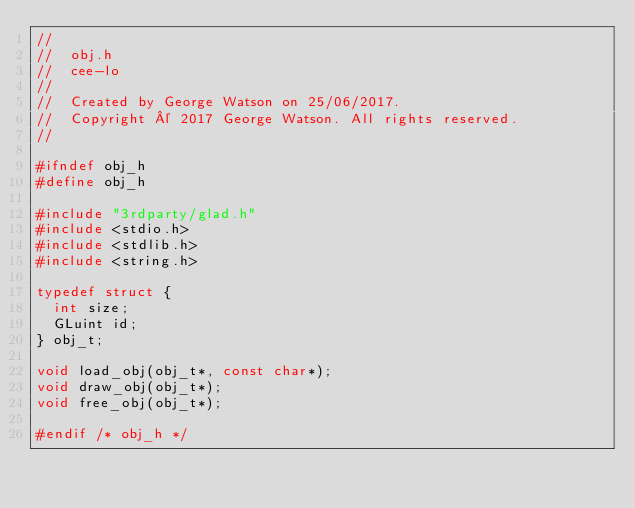<code> <loc_0><loc_0><loc_500><loc_500><_C_>//
//  obj.h
//  cee-lo
//
//  Created by George Watson on 25/06/2017.
//  Copyright © 2017 George Watson. All rights reserved.
//

#ifndef obj_h
#define obj_h

#include "3rdparty/glad.h"
#include <stdio.h>
#include <stdlib.h>
#include <string.h>

typedef struct {
  int size;
  GLuint id;
} obj_t;

void load_obj(obj_t*, const char*);
void draw_obj(obj_t*);
void free_obj(obj_t*);

#endif /* obj_h */
</code> 